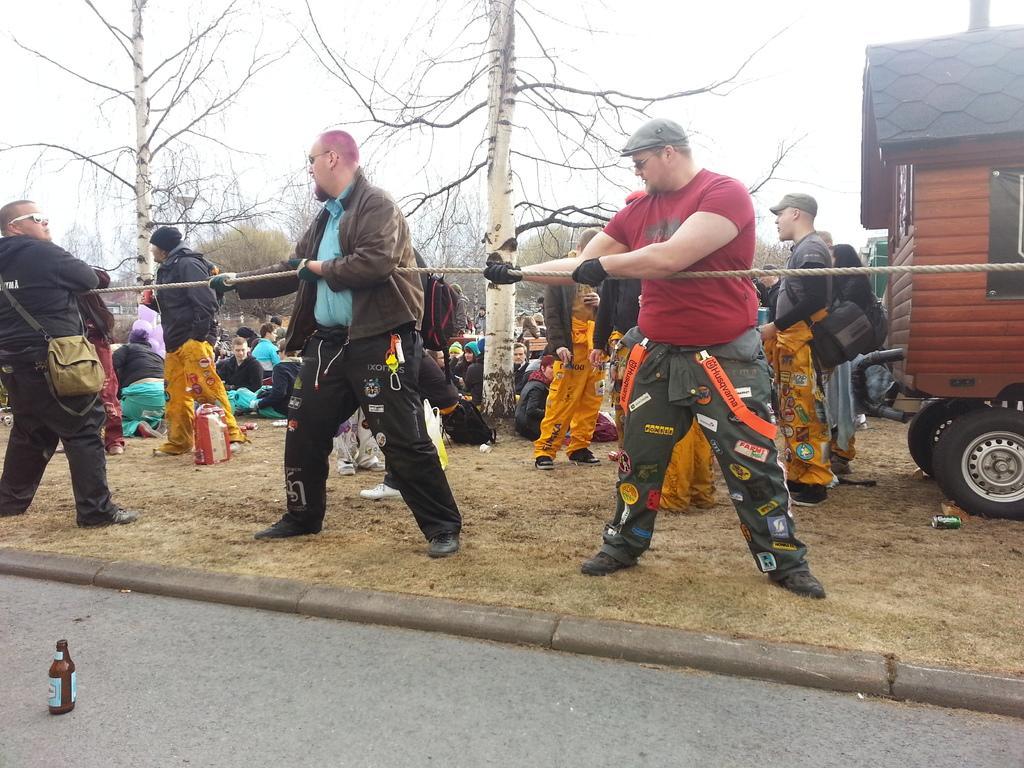Could you give a brief overview of what you see in this image? In this image we can see some people and among them three people are holding a rope and pulling it and we can see a bottle on the road. There are some trees in the background and there is a vehicle on the right side of the image. 